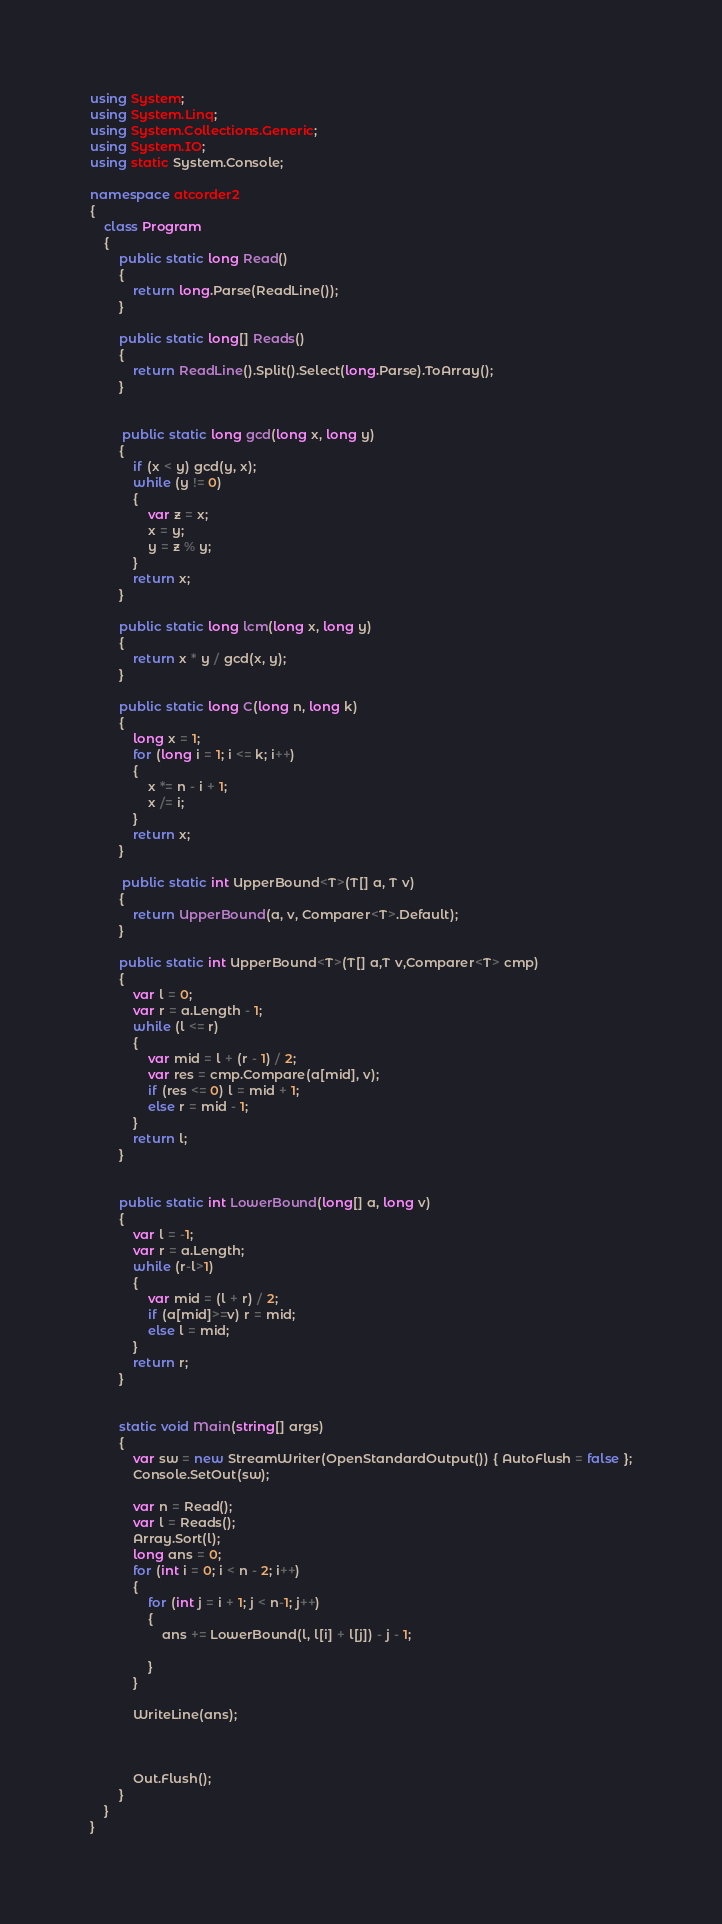<code> <loc_0><loc_0><loc_500><loc_500><_C#_>using System;
using System.Linq;
using System.Collections.Generic;
using System.IO;
using static System.Console;

namespace atcorder2
{
    class Program
    {
        public static long Read()
        {
            return long.Parse(ReadLine());
        }

        public static long[] Reads()
        {
            return ReadLine().Split().Select(long.Parse).ToArray();
        }

        
         public static long gcd(long x, long y)
        {
            if (x < y) gcd(y, x);
            while (y != 0)
            {
                var z = x;
                x = y;
                y = z % y;
            }
            return x;
        }

        public static long lcm(long x, long y)
        {
            return x * y / gcd(x, y);
        } 

        public static long C(long n, long k)
        {
            long x = 1;
            for (long i = 1; i <= k; i++)
            {
                x *= n - i + 1;
                x /= i;
            }
            return x;
        }

         public static int UpperBound<T>(T[] a, T v)
        {
            return UpperBound(a, v, Comparer<T>.Default);
        }

        public static int UpperBound<T>(T[] a,T v,Comparer<T> cmp)
        {
            var l = 0;
            var r = a.Length - 1;
            while (l <= r)
            {
                var mid = l + (r - 1) / 2;
                var res = cmp.Compare(a[mid], v);
                if (res <= 0) l = mid + 1;
                else r = mid - 1;
            }
            return l;
        }

       
        public static int LowerBound(long[] a, long v)
        {
            var l = -1;
            var r = a.Length;
            while (r-l>1)
            {
                var mid = (l + r) / 2;          
                if (a[mid]>=v) r = mid;
                else l = mid;
            }
            return r;
        }


        static void Main(string[] args)
        {
            var sw = new StreamWriter(OpenStandardOutput()) { AutoFlush = false };
            Console.SetOut(sw);

            var n = Read();
            var l = Reads();
            Array.Sort(l); 
            long ans = 0;
            for (int i = 0; i < n - 2; i++)
            {
                for (int j = i + 1; j < n-1; j++)
                {
                    ans += LowerBound(l, l[i] + l[j]) - j - 1;
                
                }
            }
           
            WriteLine(ans);

            

            Out.Flush();
        }
    }
}
</code> 